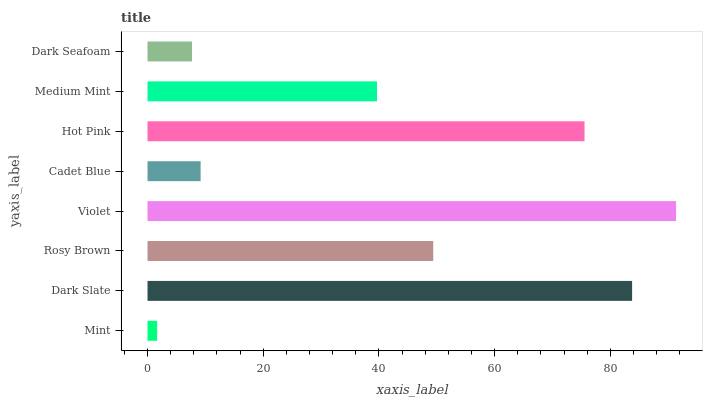Is Mint the minimum?
Answer yes or no. Yes. Is Violet the maximum?
Answer yes or no. Yes. Is Dark Slate the minimum?
Answer yes or no. No. Is Dark Slate the maximum?
Answer yes or no. No. Is Dark Slate greater than Mint?
Answer yes or no. Yes. Is Mint less than Dark Slate?
Answer yes or no. Yes. Is Mint greater than Dark Slate?
Answer yes or no. No. Is Dark Slate less than Mint?
Answer yes or no. No. Is Rosy Brown the high median?
Answer yes or no. Yes. Is Medium Mint the low median?
Answer yes or no. Yes. Is Dark Slate the high median?
Answer yes or no. No. Is Rosy Brown the low median?
Answer yes or no. No. 